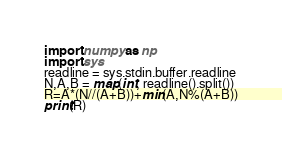Convert code to text. <code><loc_0><loc_0><loc_500><loc_500><_Python_>import numpy as np
import sys
readline = sys.stdin.buffer.readline
N,A,B = map(int, readline().split())
R=A*(N//(A+B))+min(A,N%(A+B))
print(R)</code> 